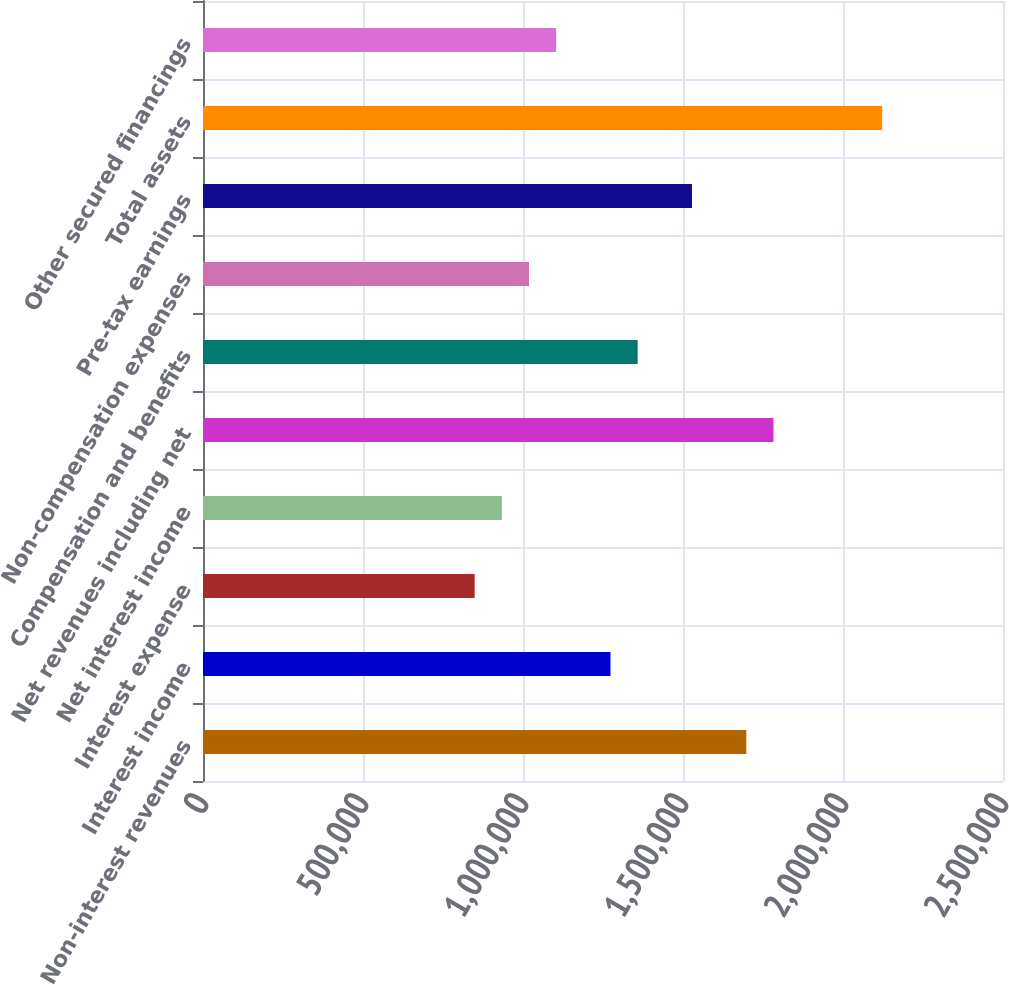Convert chart to OTSL. <chart><loc_0><loc_0><loc_500><loc_500><bar_chart><fcel>Non-interest revenues<fcel>Interest income<fcel>Interest expense<fcel>Net interest income<fcel>Net revenues including net<fcel>Compensation and benefits<fcel>Non-compensation expenses<fcel>Pre-tax earnings<fcel>Total assets<fcel>Other secured financings<nl><fcel>1.69788e+06<fcel>1.27341e+06<fcel>848942<fcel>933836<fcel>1.78278e+06<fcel>1.35831e+06<fcel>1.01873e+06<fcel>1.52809e+06<fcel>2.12235e+06<fcel>1.10362e+06<nl></chart> 